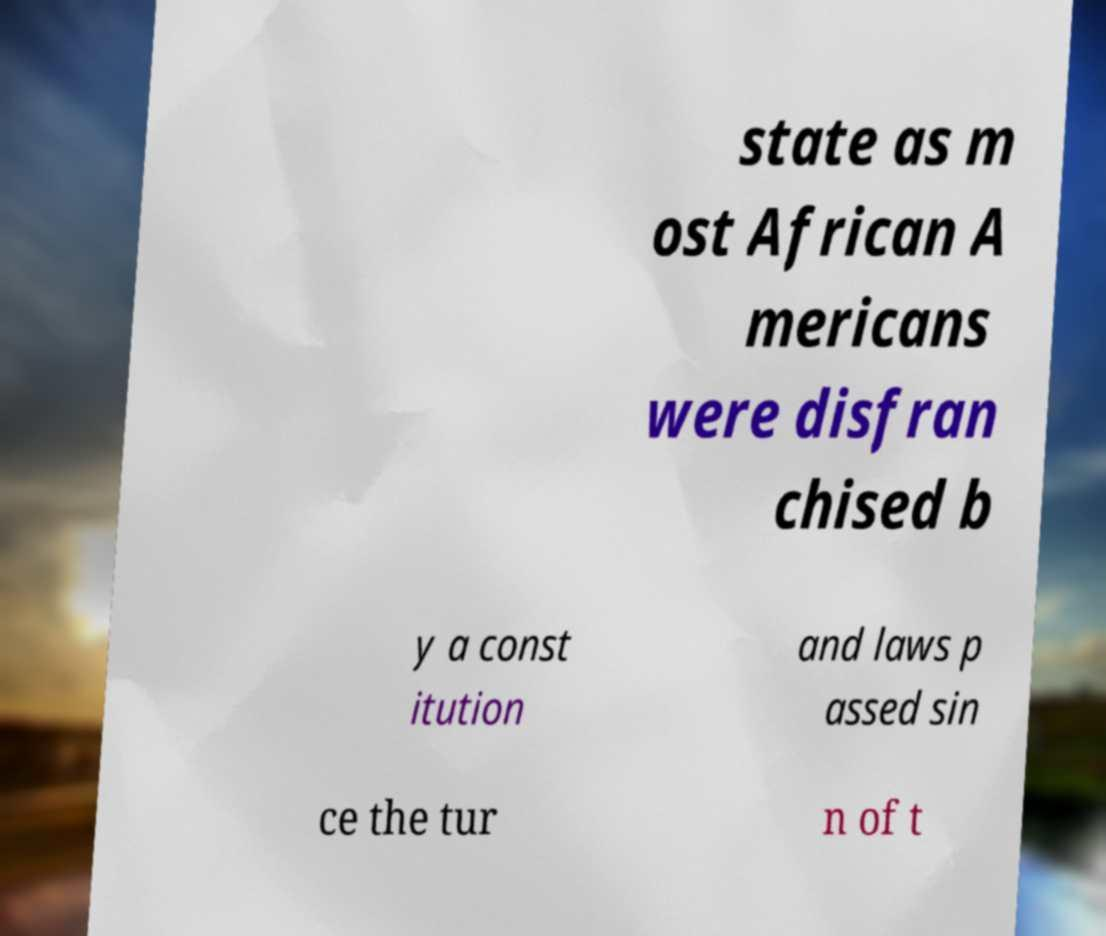I need the written content from this picture converted into text. Can you do that? state as m ost African A mericans were disfran chised b y a const itution and laws p assed sin ce the tur n of t 